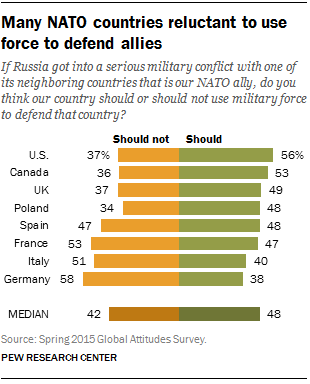Point out several critical features in this image. The percentage value of the Should bar in the U.S. is 56%. 